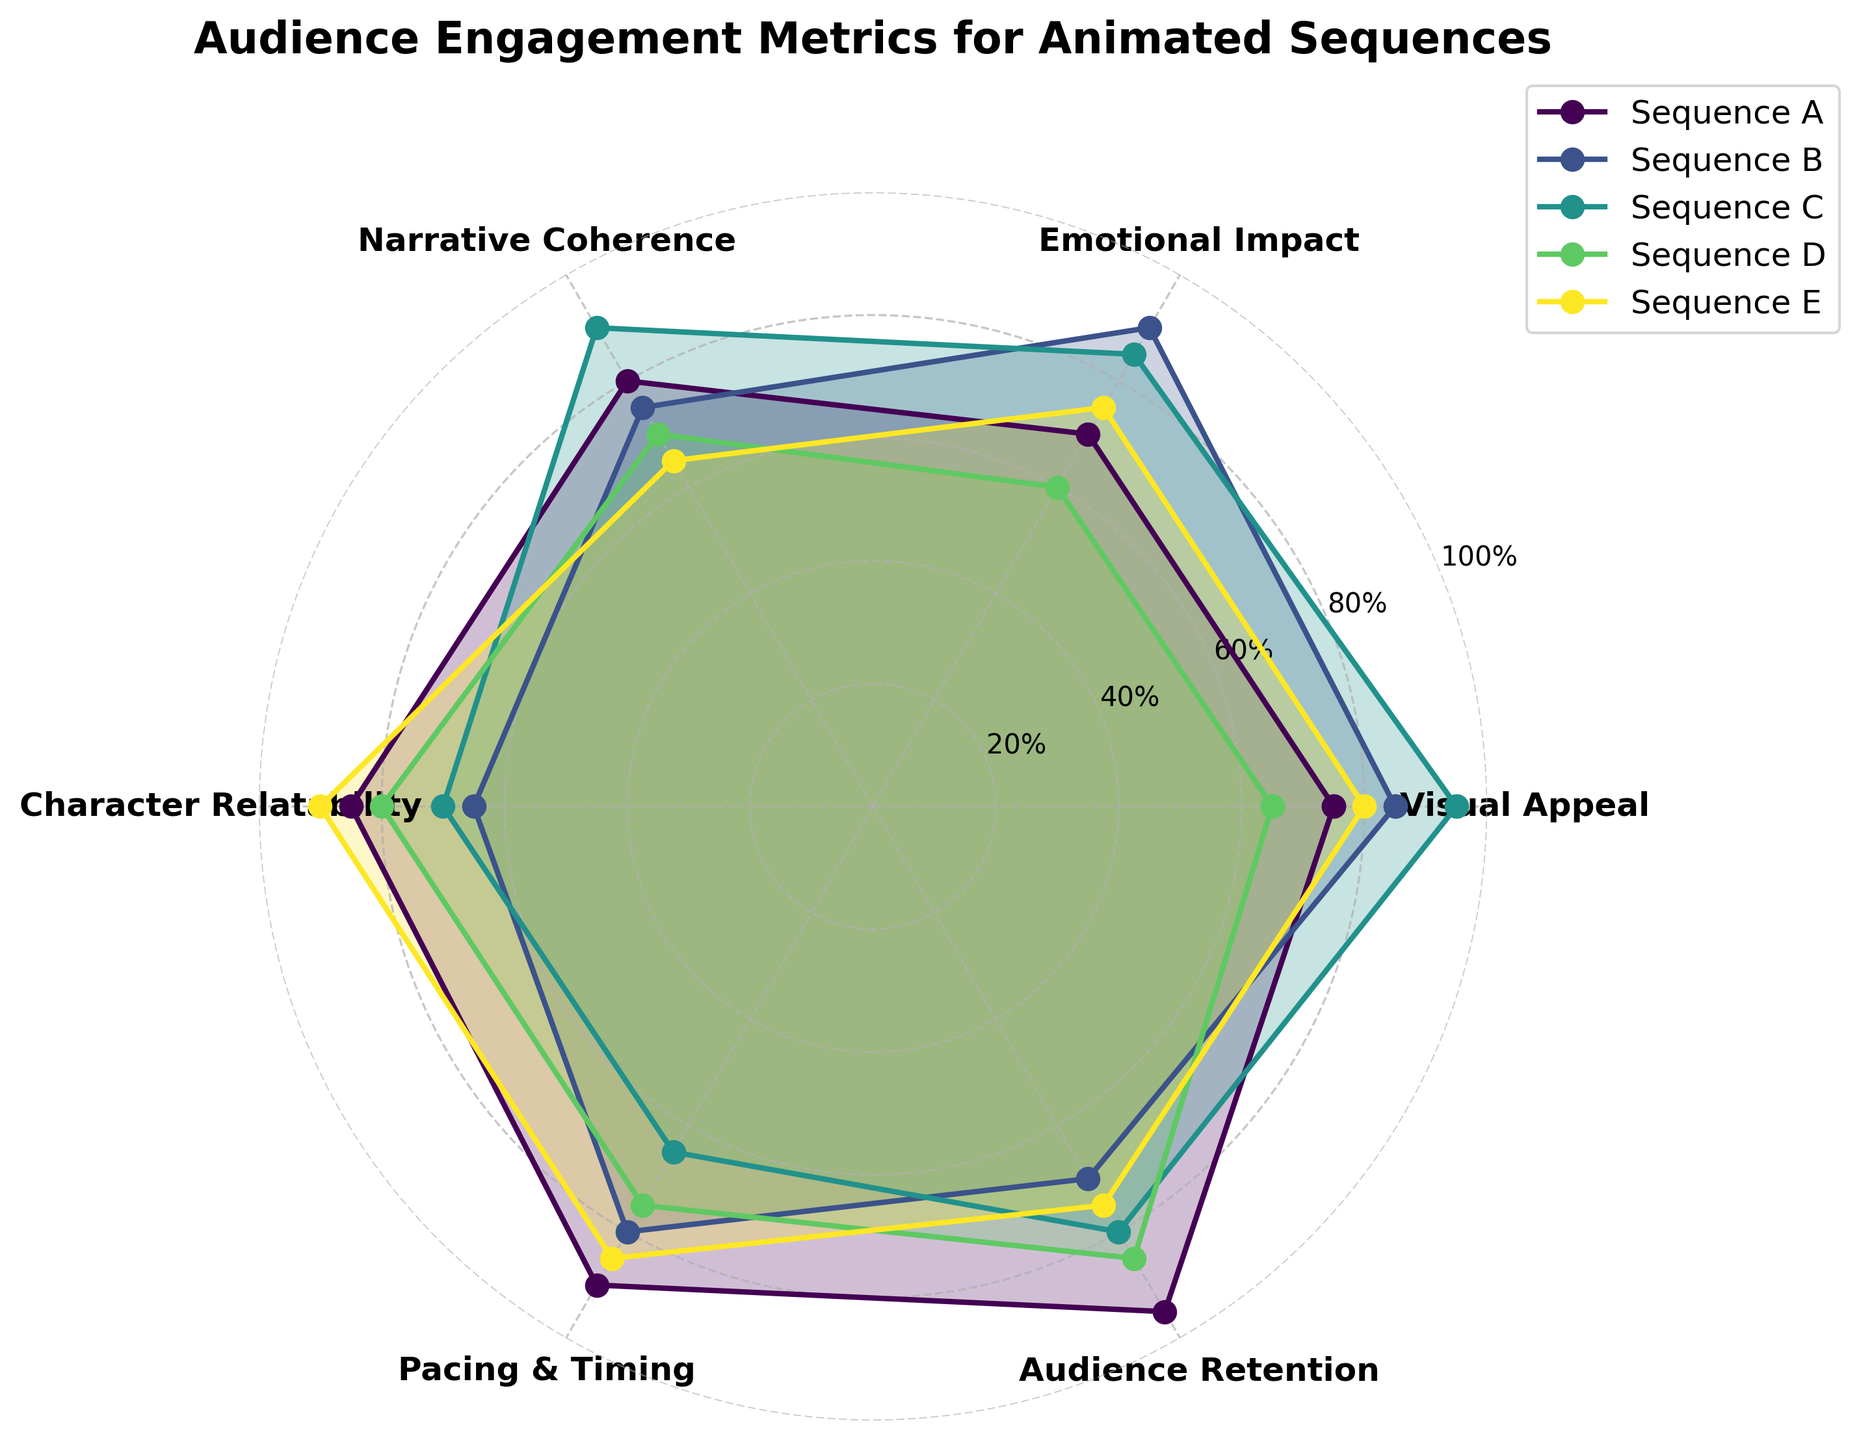what is the title of the radar chart? The title is typically found at the top of the chart, clearly labeling what the chart represents. The title "Audience Engagement Metrics for Animated Sequences" is displayed prominently.
Answer: Audience Engagement Metrics for Animated Sequences How many categories are displayed in the radar chart? To determine the number of categories, count the distinct labels around the perimeter of the radar chart used to assess the sequences. There are six categories shown.
Answer: Six Which sequence has the highest rating in Visual Appeal? By looking at the point furthest from the center for the Visual Appeal category, it represents the highest value. Sequence C has the highest value, which is at 95.
Answer: Sequence C Which category does Sequence D perform the best in? Identify the highest value point for Sequence D across all categories. The highest value for Sequence D is in the Audience Retention category, which is 85.
Answer: Audience Retention Which sequences have higher Pacing & Timing than Sequence C? Compare the values of the Pacing & Timing category for each sequence. Sequence A (90), Sequence B (80), Sequence D (75), and Sequence E (85) all have higher values than Sequence C (65).
Answer: Sequences A, B, D, E What is the overall trend for Emotional Impact scores among all sequences? Look at the plotted points for Emotional Impact for all sequences to see the range and distribution of values. Sequence B has the highest score (90), followed by Sequence C (85), Sequence E (75), Sequence A (70), and Sequence D (60).
Answer: Sequence B Between Sequences A and E, which category shows the largest difference in values? Calculate the difference for each category between Sequences A and E, then find the highest. The largest difference is in Character Relatability, where Sequence A scores 85 and Sequence E scores 90 (difference of 25).
Answer: Character Relatability Is the Pacing & Timing score for Sequence B above or below the median value of all sequences for this category? Arrange the Pacing & Timing scores and find the median value among Sequences A (90), B (80), C (65), D (75), E (85). Sequence B's score of 80 is below the median value, which is 80.
Answer: Below Which sequence has the most consistent performance across all categories? Look at the spread and variation of values for each sequence. Sequence A has values close together (ranging from 70 to 95) compared to others with greater variation.
Answer: Sequence A How do Sequence A's values in Narrative Coherence compare to Sequence E's values in the same category? Compare the values directly from the chart for Narrative Coherence. Sequence A has 80, and Sequence E has 65, so Sequence A is higher.
Answer: Sequence A has higher values 